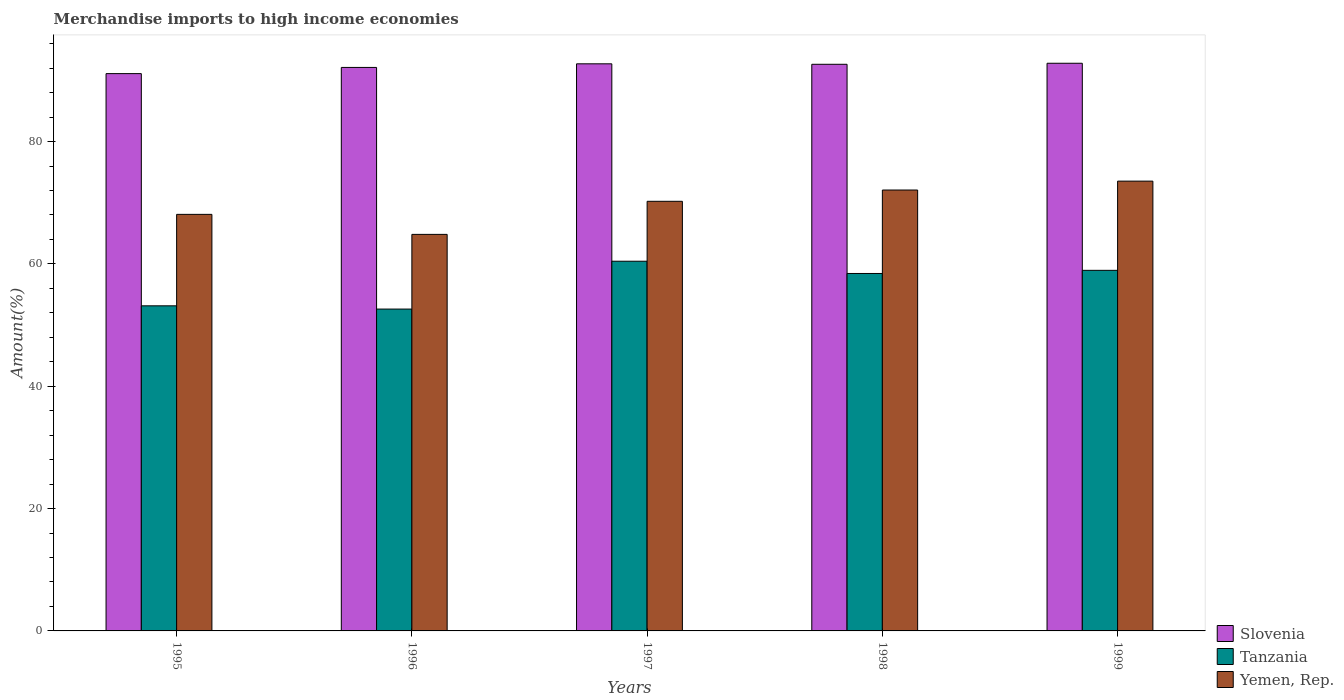Are the number of bars on each tick of the X-axis equal?
Offer a very short reply. Yes. How many bars are there on the 2nd tick from the left?
Your response must be concise. 3. In how many cases, is the number of bars for a given year not equal to the number of legend labels?
Make the answer very short. 0. What is the percentage of amount earned from merchandise imports in Slovenia in 1998?
Provide a short and direct response. 92.63. Across all years, what is the maximum percentage of amount earned from merchandise imports in Tanzania?
Provide a succinct answer. 60.43. Across all years, what is the minimum percentage of amount earned from merchandise imports in Slovenia?
Provide a short and direct response. 91.1. In which year was the percentage of amount earned from merchandise imports in Yemen, Rep. maximum?
Make the answer very short. 1999. What is the total percentage of amount earned from merchandise imports in Yemen, Rep. in the graph?
Your answer should be compact. 348.75. What is the difference between the percentage of amount earned from merchandise imports in Slovenia in 1997 and that in 1999?
Offer a very short reply. -0.09. What is the difference between the percentage of amount earned from merchandise imports in Slovenia in 1999 and the percentage of amount earned from merchandise imports in Yemen, Rep. in 1995?
Make the answer very short. 24.7. What is the average percentage of amount earned from merchandise imports in Yemen, Rep. per year?
Provide a succinct answer. 69.75. In the year 1998, what is the difference between the percentage of amount earned from merchandise imports in Slovenia and percentage of amount earned from merchandise imports in Tanzania?
Your response must be concise. 34.19. What is the ratio of the percentage of amount earned from merchandise imports in Yemen, Rep. in 1995 to that in 1998?
Give a very brief answer. 0.94. What is the difference between the highest and the second highest percentage of amount earned from merchandise imports in Tanzania?
Offer a very short reply. 1.49. What is the difference between the highest and the lowest percentage of amount earned from merchandise imports in Slovenia?
Your answer should be compact. 1.69. In how many years, is the percentage of amount earned from merchandise imports in Slovenia greater than the average percentage of amount earned from merchandise imports in Slovenia taken over all years?
Your response must be concise. 3. Is the sum of the percentage of amount earned from merchandise imports in Slovenia in 1996 and 1997 greater than the maximum percentage of amount earned from merchandise imports in Yemen, Rep. across all years?
Offer a terse response. Yes. What does the 3rd bar from the left in 1996 represents?
Ensure brevity in your answer.  Yemen, Rep. What does the 3rd bar from the right in 1999 represents?
Offer a terse response. Slovenia. Is it the case that in every year, the sum of the percentage of amount earned from merchandise imports in Yemen, Rep. and percentage of amount earned from merchandise imports in Slovenia is greater than the percentage of amount earned from merchandise imports in Tanzania?
Provide a short and direct response. Yes. How many years are there in the graph?
Your answer should be very brief. 5. What is the difference between two consecutive major ticks on the Y-axis?
Provide a short and direct response. 20. Are the values on the major ticks of Y-axis written in scientific E-notation?
Your answer should be compact. No. Does the graph contain any zero values?
Give a very brief answer. No. Does the graph contain grids?
Your answer should be very brief. No. Where does the legend appear in the graph?
Provide a short and direct response. Bottom right. How are the legend labels stacked?
Keep it short and to the point. Vertical. What is the title of the graph?
Provide a succinct answer. Merchandise imports to high income economies. What is the label or title of the X-axis?
Your answer should be compact. Years. What is the label or title of the Y-axis?
Ensure brevity in your answer.  Amount(%). What is the Amount(%) in Slovenia in 1995?
Your answer should be compact. 91.1. What is the Amount(%) of Tanzania in 1995?
Your response must be concise. 53.14. What is the Amount(%) of Yemen, Rep. in 1995?
Your answer should be compact. 68.1. What is the Amount(%) in Slovenia in 1996?
Provide a succinct answer. 92.11. What is the Amount(%) in Tanzania in 1996?
Keep it short and to the point. 52.61. What is the Amount(%) in Yemen, Rep. in 1996?
Provide a succinct answer. 64.82. What is the Amount(%) in Slovenia in 1997?
Your answer should be compact. 92.71. What is the Amount(%) in Tanzania in 1997?
Offer a terse response. 60.43. What is the Amount(%) of Yemen, Rep. in 1997?
Offer a terse response. 70.23. What is the Amount(%) in Slovenia in 1998?
Make the answer very short. 92.63. What is the Amount(%) in Tanzania in 1998?
Provide a succinct answer. 58.43. What is the Amount(%) in Yemen, Rep. in 1998?
Give a very brief answer. 72.07. What is the Amount(%) of Slovenia in 1999?
Make the answer very short. 92.8. What is the Amount(%) of Tanzania in 1999?
Ensure brevity in your answer.  58.94. What is the Amount(%) in Yemen, Rep. in 1999?
Your response must be concise. 73.53. Across all years, what is the maximum Amount(%) of Slovenia?
Your response must be concise. 92.8. Across all years, what is the maximum Amount(%) in Tanzania?
Keep it short and to the point. 60.43. Across all years, what is the maximum Amount(%) in Yemen, Rep.?
Your answer should be compact. 73.53. Across all years, what is the minimum Amount(%) in Slovenia?
Your answer should be very brief. 91.1. Across all years, what is the minimum Amount(%) of Tanzania?
Your answer should be very brief. 52.61. Across all years, what is the minimum Amount(%) in Yemen, Rep.?
Give a very brief answer. 64.82. What is the total Amount(%) in Slovenia in the graph?
Your response must be concise. 461.35. What is the total Amount(%) of Tanzania in the graph?
Provide a short and direct response. 283.57. What is the total Amount(%) of Yemen, Rep. in the graph?
Offer a terse response. 348.75. What is the difference between the Amount(%) of Slovenia in 1995 and that in 1996?
Offer a very short reply. -1.01. What is the difference between the Amount(%) of Tanzania in 1995 and that in 1996?
Provide a short and direct response. 0.53. What is the difference between the Amount(%) of Yemen, Rep. in 1995 and that in 1996?
Make the answer very short. 3.27. What is the difference between the Amount(%) of Slovenia in 1995 and that in 1997?
Your answer should be very brief. -1.6. What is the difference between the Amount(%) in Tanzania in 1995 and that in 1997?
Provide a succinct answer. -7.29. What is the difference between the Amount(%) of Yemen, Rep. in 1995 and that in 1997?
Your answer should be very brief. -2.14. What is the difference between the Amount(%) in Slovenia in 1995 and that in 1998?
Make the answer very short. -1.52. What is the difference between the Amount(%) of Tanzania in 1995 and that in 1998?
Your response must be concise. -5.29. What is the difference between the Amount(%) in Yemen, Rep. in 1995 and that in 1998?
Give a very brief answer. -3.98. What is the difference between the Amount(%) in Slovenia in 1995 and that in 1999?
Provide a succinct answer. -1.69. What is the difference between the Amount(%) of Tanzania in 1995 and that in 1999?
Offer a terse response. -5.8. What is the difference between the Amount(%) in Yemen, Rep. in 1995 and that in 1999?
Your answer should be compact. -5.43. What is the difference between the Amount(%) in Slovenia in 1996 and that in 1997?
Keep it short and to the point. -0.59. What is the difference between the Amount(%) in Tanzania in 1996 and that in 1997?
Your answer should be compact. -7.82. What is the difference between the Amount(%) in Yemen, Rep. in 1996 and that in 1997?
Give a very brief answer. -5.41. What is the difference between the Amount(%) of Slovenia in 1996 and that in 1998?
Your answer should be compact. -0.51. What is the difference between the Amount(%) in Tanzania in 1996 and that in 1998?
Your answer should be very brief. -5.82. What is the difference between the Amount(%) of Yemen, Rep. in 1996 and that in 1998?
Give a very brief answer. -7.25. What is the difference between the Amount(%) in Slovenia in 1996 and that in 1999?
Ensure brevity in your answer.  -0.68. What is the difference between the Amount(%) of Tanzania in 1996 and that in 1999?
Provide a short and direct response. -6.33. What is the difference between the Amount(%) in Yemen, Rep. in 1996 and that in 1999?
Offer a terse response. -8.71. What is the difference between the Amount(%) of Slovenia in 1997 and that in 1998?
Provide a short and direct response. 0.08. What is the difference between the Amount(%) in Tanzania in 1997 and that in 1998?
Offer a terse response. 2. What is the difference between the Amount(%) of Yemen, Rep. in 1997 and that in 1998?
Your answer should be compact. -1.84. What is the difference between the Amount(%) of Slovenia in 1997 and that in 1999?
Provide a short and direct response. -0.09. What is the difference between the Amount(%) of Tanzania in 1997 and that in 1999?
Keep it short and to the point. 1.49. What is the difference between the Amount(%) of Yemen, Rep. in 1997 and that in 1999?
Keep it short and to the point. -3.3. What is the difference between the Amount(%) in Slovenia in 1998 and that in 1999?
Offer a terse response. -0.17. What is the difference between the Amount(%) in Tanzania in 1998 and that in 1999?
Keep it short and to the point. -0.51. What is the difference between the Amount(%) in Yemen, Rep. in 1998 and that in 1999?
Your answer should be compact. -1.45. What is the difference between the Amount(%) in Slovenia in 1995 and the Amount(%) in Tanzania in 1996?
Provide a short and direct response. 38.49. What is the difference between the Amount(%) in Slovenia in 1995 and the Amount(%) in Yemen, Rep. in 1996?
Keep it short and to the point. 26.28. What is the difference between the Amount(%) of Tanzania in 1995 and the Amount(%) of Yemen, Rep. in 1996?
Ensure brevity in your answer.  -11.68. What is the difference between the Amount(%) in Slovenia in 1995 and the Amount(%) in Tanzania in 1997?
Give a very brief answer. 30.67. What is the difference between the Amount(%) of Slovenia in 1995 and the Amount(%) of Yemen, Rep. in 1997?
Provide a succinct answer. 20.87. What is the difference between the Amount(%) of Tanzania in 1995 and the Amount(%) of Yemen, Rep. in 1997?
Your response must be concise. -17.09. What is the difference between the Amount(%) of Slovenia in 1995 and the Amount(%) of Tanzania in 1998?
Provide a succinct answer. 32.67. What is the difference between the Amount(%) of Slovenia in 1995 and the Amount(%) of Yemen, Rep. in 1998?
Make the answer very short. 19.03. What is the difference between the Amount(%) in Tanzania in 1995 and the Amount(%) in Yemen, Rep. in 1998?
Your answer should be compact. -18.93. What is the difference between the Amount(%) in Slovenia in 1995 and the Amount(%) in Tanzania in 1999?
Provide a short and direct response. 32.16. What is the difference between the Amount(%) of Slovenia in 1995 and the Amount(%) of Yemen, Rep. in 1999?
Keep it short and to the point. 17.57. What is the difference between the Amount(%) of Tanzania in 1995 and the Amount(%) of Yemen, Rep. in 1999?
Give a very brief answer. -20.38. What is the difference between the Amount(%) of Slovenia in 1996 and the Amount(%) of Tanzania in 1997?
Your answer should be compact. 31.68. What is the difference between the Amount(%) in Slovenia in 1996 and the Amount(%) in Yemen, Rep. in 1997?
Offer a terse response. 21.88. What is the difference between the Amount(%) of Tanzania in 1996 and the Amount(%) of Yemen, Rep. in 1997?
Provide a succinct answer. -17.62. What is the difference between the Amount(%) in Slovenia in 1996 and the Amount(%) in Tanzania in 1998?
Make the answer very short. 33.68. What is the difference between the Amount(%) in Slovenia in 1996 and the Amount(%) in Yemen, Rep. in 1998?
Your response must be concise. 20.04. What is the difference between the Amount(%) in Tanzania in 1996 and the Amount(%) in Yemen, Rep. in 1998?
Your answer should be compact. -19.46. What is the difference between the Amount(%) in Slovenia in 1996 and the Amount(%) in Tanzania in 1999?
Ensure brevity in your answer.  33.17. What is the difference between the Amount(%) in Slovenia in 1996 and the Amount(%) in Yemen, Rep. in 1999?
Make the answer very short. 18.59. What is the difference between the Amount(%) in Tanzania in 1996 and the Amount(%) in Yemen, Rep. in 1999?
Offer a terse response. -20.91. What is the difference between the Amount(%) in Slovenia in 1997 and the Amount(%) in Tanzania in 1998?
Provide a short and direct response. 34.27. What is the difference between the Amount(%) in Slovenia in 1997 and the Amount(%) in Yemen, Rep. in 1998?
Offer a very short reply. 20.63. What is the difference between the Amount(%) in Tanzania in 1997 and the Amount(%) in Yemen, Rep. in 1998?
Ensure brevity in your answer.  -11.64. What is the difference between the Amount(%) in Slovenia in 1997 and the Amount(%) in Tanzania in 1999?
Make the answer very short. 33.76. What is the difference between the Amount(%) of Slovenia in 1997 and the Amount(%) of Yemen, Rep. in 1999?
Keep it short and to the point. 19.18. What is the difference between the Amount(%) of Tanzania in 1997 and the Amount(%) of Yemen, Rep. in 1999?
Keep it short and to the point. -13.09. What is the difference between the Amount(%) of Slovenia in 1998 and the Amount(%) of Tanzania in 1999?
Keep it short and to the point. 33.68. What is the difference between the Amount(%) of Slovenia in 1998 and the Amount(%) of Yemen, Rep. in 1999?
Your answer should be compact. 19.1. What is the difference between the Amount(%) of Tanzania in 1998 and the Amount(%) of Yemen, Rep. in 1999?
Your response must be concise. -15.1. What is the average Amount(%) in Slovenia per year?
Your answer should be very brief. 92.27. What is the average Amount(%) of Tanzania per year?
Provide a succinct answer. 56.71. What is the average Amount(%) in Yemen, Rep. per year?
Provide a succinct answer. 69.75. In the year 1995, what is the difference between the Amount(%) of Slovenia and Amount(%) of Tanzania?
Offer a terse response. 37.96. In the year 1995, what is the difference between the Amount(%) of Slovenia and Amount(%) of Yemen, Rep.?
Your response must be concise. 23.01. In the year 1995, what is the difference between the Amount(%) of Tanzania and Amount(%) of Yemen, Rep.?
Give a very brief answer. -14.95. In the year 1996, what is the difference between the Amount(%) of Slovenia and Amount(%) of Tanzania?
Give a very brief answer. 39.5. In the year 1996, what is the difference between the Amount(%) of Slovenia and Amount(%) of Yemen, Rep.?
Offer a terse response. 27.29. In the year 1996, what is the difference between the Amount(%) of Tanzania and Amount(%) of Yemen, Rep.?
Provide a succinct answer. -12.21. In the year 1997, what is the difference between the Amount(%) in Slovenia and Amount(%) in Tanzania?
Make the answer very short. 32.27. In the year 1997, what is the difference between the Amount(%) in Slovenia and Amount(%) in Yemen, Rep.?
Give a very brief answer. 22.47. In the year 1997, what is the difference between the Amount(%) in Tanzania and Amount(%) in Yemen, Rep.?
Keep it short and to the point. -9.8. In the year 1998, what is the difference between the Amount(%) of Slovenia and Amount(%) of Tanzania?
Your answer should be compact. 34.19. In the year 1998, what is the difference between the Amount(%) of Slovenia and Amount(%) of Yemen, Rep.?
Keep it short and to the point. 20.55. In the year 1998, what is the difference between the Amount(%) of Tanzania and Amount(%) of Yemen, Rep.?
Your response must be concise. -13.64. In the year 1999, what is the difference between the Amount(%) of Slovenia and Amount(%) of Tanzania?
Provide a short and direct response. 33.85. In the year 1999, what is the difference between the Amount(%) in Slovenia and Amount(%) in Yemen, Rep.?
Keep it short and to the point. 19.27. In the year 1999, what is the difference between the Amount(%) in Tanzania and Amount(%) in Yemen, Rep.?
Provide a succinct answer. -14.58. What is the ratio of the Amount(%) in Slovenia in 1995 to that in 1996?
Provide a short and direct response. 0.99. What is the ratio of the Amount(%) in Tanzania in 1995 to that in 1996?
Your answer should be compact. 1.01. What is the ratio of the Amount(%) of Yemen, Rep. in 1995 to that in 1996?
Your answer should be compact. 1.05. What is the ratio of the Amount(%) in Slovenia in 1995 to that in 1997?
Your response must be concise. 0.98. What is the ratio of the Amount(%) in Tanzania in 1995 to that in 1997?
Your answer should be compact. 0.88. What is the ratio of the Amount(%) in Yemen, Rep. in 1995 to that in 1997?
Ensure brevity in your answer.  0.97. What is the ratio of the Amount(%) in Slovenia in 1995 to that in 1998?
Keep it short and to the point. 0.98. What is the ratio of the Amount(%) in Tanzania in 1995 to that in 1998?
Your response must be concise. 0.91. What is the ratio of the Amount(%) of Yemen, Rep. in 1995 to that in 1998?
Your response must be concise. 0.94. What is the ratio of the Amount(%) in Slovenia in 1995 to that in 1999?
Offer a very short reply. 0.98. What is the ratio of the Amount(%) in Tanzania in 1995 to that in 1999?
Your response must be concise. 0.9. What is the ratio of the Amount(%) of Yemen, Rep. in 1995 to that in 1999?
Provide a succinct answer. 0.93. What is the ratio of the Amount(%) in Tanzania in 1996 to that in 1997?
Keep it short and to the point. 0.87. What is the ratio of the Amount(%) in Yemen, Rep. in 1996 to that in 1997?
Provide a short and direct response. 0.92. What is the ratio of the Amount(%) of Tanzania in 1996 to that in 1998?
Provide a short and direct response. 0.9. What is the ratio of the Amount(%) of Yemen, Rep. in 1996 to that in 1998?
Provide a short and direct response. 0.9. What is the ratio of the Amount(%) of Tanzania in 1996 to that in 1999?
Your response must be concise. 0.89. What is the ratio of the Amount(%) in Yemen, Rep. in 1996 to that in 1999?
Provide a short and direct response. 0.88. What is the ratio of the Amount(%) of Tanzania in 1997 to that in 1998?
Offer a terse response. 1.03. What is the ratio of the Amount(%) of Yemen, Rep. in 1997 to that in 1998?
Ensure brevity in your answer.  0.97. What is the ratio of the Amount(%) of Slovenia in 1997 to that in 1999?
Your response must be concise. 1. What is the ratio of the Amount(%) of Tanzania in 1997 to that in 1999?
Provide a short and direct response. 1.03. What is the ratio of the Amount(%) in Yemen, Rep. in 1997 to that in 1999?
Offer a very short reply. 0.96. What is the ratio of the Amount(%) in Yemen, Rep. in 1998 to that in 1999?
Provide a succinct answer. 0.98. What is the difference between the highest and the second highest Amount(%) in Slovenia?
Ensure brevity in your answer.  0.09. What is the difference between the highest and the second highest Amount(%) in Tanzania?
Offer a terse response. 1.49. What is the difference between the highest and the second highest Amount(%) in Yemen, Rep.?
Provide a short and direct response. 1.45. What is the difference between the highest and the lowest Amount(%) of Slovenia?
Your response must be concise. 1.69. What is the difference between the highest and the lowest Amount(%) of Tanzania?
Your answer should be very brief. 7.82. What is the difference between the highest and the lowest Amount(%) of Yemen, Rep.?
Your answer should be very brief. 8.71. 